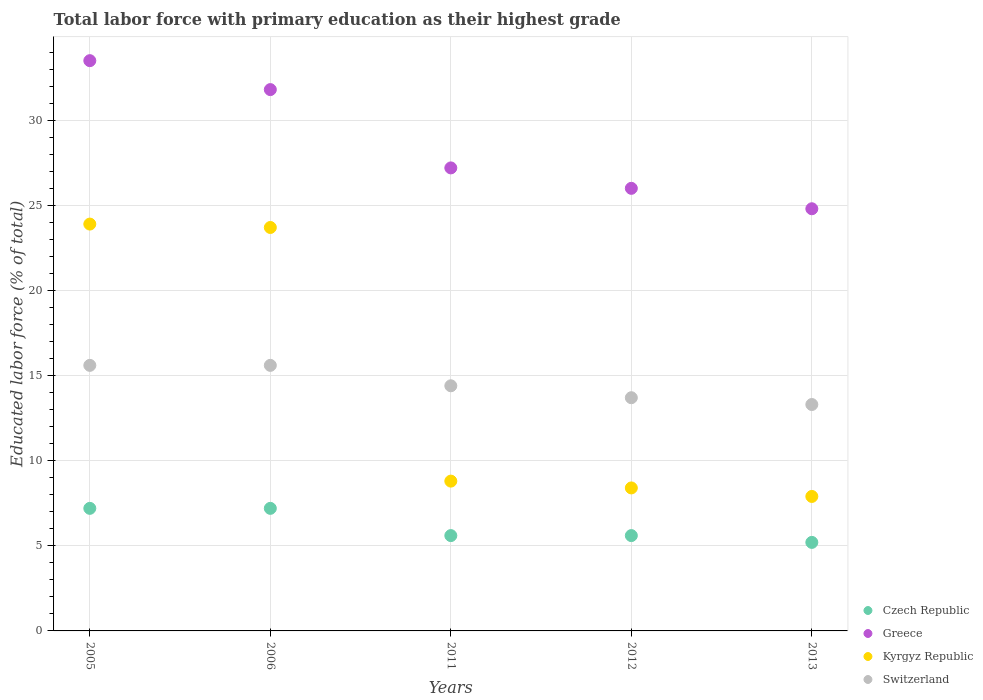What is the percentage of total labor force with primary education in Greece in 2011?
Provide a succinct answer. 27.2. Across all years, what is the maximum percentage of total labor force with primary education in Kyrgyz Republic?
Ensure brevity in your answer.  23.9. Across all years, what is the minimum percentage of total labor force with primary education in Switzerland?
Offer a terse response. 13.3. In which year was the percentage of total labor force with primary education in Greece maximum?
Your response must be concise. 2005. In which year was the percentage of total labor force with primary education in Kyrgyz Republic minimum?
Your answer should be compact. 2013. What is the total percentage of total labor force with primary education in Greece in the graph?
Offer a very short reply. 143.3. What is the difference between the percentage of total labor force with primary education in Czech Republic in 2011 and that in 2013?
Your answer should be compact. 0.4. What is the difference between the percentage of total labor force with primary education in Greece in 2006 and the percentage of total labor force with primary education in Switzerland in 2011?
Your response must be concise. 17.4. What is the average percentage of total labor force with primary education in Kyrgyz Republic per year?
Offer a terse response. 14.54. In the year 2006, what is the difference between the percentage of total labor force with primary education in Switzerland and percentage of total labor force with primary education in Czech Republic?
Keep it short and to the point. 8.4. What is the ratio of the percentage of total labor force with primary education in Switzerland in 2012 to that in 2013?
Give a very brief answer. 1.03. Is the percentage of total labor force with primary education in Czech Republic in 2005 less than that in 2011?
Provide a short and direct response. No. What is the difference between the highest and the second highest percentage of total labor force with primary education in Kyrgyz Republic?
Your response must be concise. 0.2. What is the difference between the highest and the lowest percentage of total labor force with primary education in Kyrgyz Republic?
Give a very brief answer. 16. How many dotlines are there?
Make the answer very short. 4. Does the graph contain any zero values?
Your answer should be compact. No. Does the graph contain grids?
Your response must be concise. Yes. How many legend labels are there?
Keep it short and to the point. 4. What is the title of the graph?
Give a very brief answer. Total labor force with primary education as their highest grade. Does "Mongolia" appear as one of the legend labels in the graph?
Provide a short and direct response. No. What is the label or title of the X-axis?
Offer a terse response. Years. What is the label or title of the Y-axis?
Your answer should be compact. Educated labor force (% of total). What is the Educated labor force (% of total) in Czech Republic in 2005?
Give a very brief answer. 7.2. What is the Educated labor force (% of total) in Greece in 2005?
Offer a terse response. 33.5. What is the Educated labor force (% of total) of Kyrgyz Republic in 2005?
Make the answer very short. 23.9. What is the Educated labor force (% of total) of Switzerland in 2005?
Make the answer very short. 15.6. What is the Educated labor force (% of total) in Czech Republic in 2006?
Your answer should be very brief. 7.2. What is the Educated labor force (% of total) of Greece in 2006?
Provide a short and direct response. 31.8. What is the Educated labor force (% of total) of Kyrgyz Republic in 2006?
Offer a very short reply. 23.7. What is the Educated labor force (% of total) of Switzerland in 2006?
Provide a short and direct response. 15.6. What is the Educated labor force (% of total) of Czech Republic in 2011?
Keep it short and to the point. 5.6. What is the Educated labor force (% of total) of Greece in 2011?
Offer a very short reply. 27.2. What is the Educated labor force (% of total) of Kyrgyz Republic in 2011?
Keep it short and to the point. 8.8. What is the Educated labor force (% of total) in Switzerland in 2011?
Offer a terse response. 14.4. What is the Educated labor force (% of total) in Czech Republic in 2012?
Provide a short and direct response. 5.6. What is the Educated labor force (% of total) in Kyrgyz Republic in 2012?
Offer a very short reply. 8.4. What is the Educated labor force (% of total) in Switzerland in 2012?
Your answer should be very brief. 13.7. What is the Educated labor force (% of total) in Czech Republic in 2013?
Make the answer very short. 5.2. What is the Educated labor force (% of total) in Greece in 2013?
Give a very brief answer. 24.8. What is the Educated labor force (% of total) of Kyrgyz Republic in 2013?
Ensure brevity in your answer.  7.9. What is the Educated labor force (% of total) of Switzerland in 2013?
Offer a terse response. 13.3. Across all years, what is the maximum Educated labor force (% of total) of Czech Republic?
Your response must be concise. 7.2. Across all years, what is the maximum Educated labor force (% of total) in Greece?
Make the answer very short. 33.5. Across all years, what is the maximum Educated labor force (% of total) in Kyrgyz Republic?
Your answer should be compact. 23.9. Across all years, what is the maximum Educated labor force (% of total) of Switzerland?
Your response must be concise. 15.6. Across all years, what is the minimum Educated labor force (% of total) of Czech Republic?
Provide a short and direct response. 5.2. Across all years, what is the minimum Educated labor force (% of total) of Greece?
Offer a very short reply. 24.8. Across all years, what is the minimum Educated labor force (% of total) in Kyrgyz Republic?
Offer a terse response. 7.9. Across all years, what is the minimum Educated labor force (% of total) in Switzerland?
Your answer should be very brief. 13.3. What is the total Educated labor force (% of total) in Czech Republic in the graph?
Give a very brief answer. 30.8. What is the total Educated labor force (% of total) of Greece in the graph?
Give a very brief answer. 143.3. What is the total Educated labor force (% of total) in Kyrgyz Republic in the graph?
Provide a succinct answer. 72.7. What is the total Educated labor force (% of total) of Switzerland in the graph?
Make the answer very short. 72.6. What is the difference between the Educated labor force (% of total) in Czech Republic in 2005 and that in 2006?
Give a very brief answer. 0. What is the difference between the Educated labor force (% of total) of Kyrgyz Republic in 2005 and that in 2006?
Offer a very short reply. 0.2. What is the difference between the Educated labor force (% of total) in Switzerland in 2005 and that in 2006?
Provide a succinct answer. 0. What is the difference between the Educated labor force (% of total) in Czech Republic in 2005 and that in 2011?
Offer a very short reply. 1.6. What is the difference between the Educated labor force (% of total) in Greece in 2005 and that in 2011?
Your answer should be compact. 6.3. What is the difference between the Educated labor force (% of total) of Kyrgyz Republic in 2005 and that in 2011?
Ensure brevity in your answer.  15.1. What is the difference between the Educated labor force (% of total) in Kyrgyz Republic in 2005 and that in 2012?
Make the answer very short. 15.5. What is the difference between the Educated labor force (% of total) in Switzerland in 2005 and that in 2012?
Provide a short and direct response. 1.9. What is the difference between the Educated labor force (% of total) of Czech Republic in 2005 and that in 2013?
Provide a short and direct response. 2. What is the difference between the Educated labor force (% of total) of Greece in 2005 and that in 2013?
Offer a very short reply. 8.7. What is the difference between the Educated labor force (% of total) in Kyrgyz Republic in 2005 and that in 2013?
Give a very brief answer. 16. What is the difference between the Educated labor force (% of total) in Switzerland in 2005 and that in 2013?
Offer a terse response. 2.3. What is the difference between the Educated labor force (% of total) of Czech Republic in 2006 and that in 2011?
Ensure brevity in your answer.  1.6. What is the difference between the Educated labor force (% of total) in Kyrgyz Republic in 2006 and that in 2011?
Make the answer very short. 14.9. What is the difference between the Educated labor force (% of total) of Switzerland in 2006 and that in 2011?
Your response must be concise. 1.2. What is the difference between the Educated labor force (% of total) of Kyrgyz Republic in 2006 and that in 2012?
Your answer should be compact. 15.3. What is the difference between the Educated labor force (% of total) in Switzerland in 2006 and that in 2012?
Ensure brevity in your answer.  1.9. What is the difference between the Educated labor force (% of total) in Czech Republic in 2006 and that in 2013?
Offer a terse response. 2. What is the difference between the Educated labor force (% of total) in Czech Republic in 2011 and that in 2012?
Offer a terse response. 0. What is the difference between the Educated labor force (% of total) of Greece in 2011 and that in 2012?
Ensure brevity in your answer.  1.2. What is the difference between the Educated labor force (% of total) in Greece in 2011 and that in 2013?
Make the answer very short. 2.4. What is the difference between the Educated labor force (% of total) in Kyrgyz Republic in 2011 and that in 2013?
Keep it short and to the point. 0.9. What is the difference between the Educated labor force (% of total) of Switzerland in 2011 and that in 2013?
Your answer should be compact. 1.1. What is the difference between the Educated labor force (% of total) of Czech Republic in 2012 and that in 2013?
Provide a succinct answer. 0.4. What is the difference between the Educated labor force (% of total) of Greece in 2012 and that in 2013?
Your answer should be very brief. 1.2. What is the difference between the Educated labor force (% of total) in Kyrgyz Republic in 2012 and that in 2013?
Keep it short and to the point. 0.5. What is the difference between the Educated labor force (% of total) of Switzerland in 2012 and that in 2013?
Ensure brevity in your answer.  0.4. What is the difference between the Educated labor force (% of total) of Czech Republic in 2005 and the Educated labor force (% of total) of Greece in 2006?
Offer a terse response. -24.6. What is the difference between the Educated labor force (% of total) in Czech Republic in 2005 and the Educated labor force (% of total) in Kyrgyz Republic in 2006?
Ensure brevity in your answer.  -16.5. What is the difference between the Educated labor force (% of total) of Greece in 2005 and the Educated labor force (% of total) of Switzerland in 2006?
Make the answer very short. 17.9. What is the difference between the Educated labor force (% of total) in Czech Republic in 2005 and the Educated labor force (% of total) in Switzerland in 2011?
Give a very brief answer. -7.2. What is the difference between the Educated labor force (% of total) of Greece in 2005 and the Educated labor force (% of total) of Kyrgyz Republic in 2011?
Keep it short and to the point. 24.7. What is the difference between the Educated labor force (% of total) in Czech Republic in 2005 and the Educated labor force (% of total) in Greece in 2012?
Keep it short and to the point. -18.8. What is the difference between the Educated labor force (% of total) in Czech Republic in 2005 and the Educated labor force (% of total) in Switzerland in 2012?
Provide a short and direct response. -6.5. What is the difference between the Educated labor force (% of total) of Greece in 2005 and the Educated labor force (% of total) of Kyrgyz Republic in 2012?
Your answer should be very brief. 25.1. What is the difference between the Educated labor force (% of total) in Greece in 2005 and the Educated labor force (% of total) in Switzerland in 2012?
Offer a very short reply. 19.8. What is the difference between the Educated labor force (% of total) in Czech Republic in 2005 and the Educated labor force (% of total) in Greece in 2013?
Provide a succinct answer. -17.6. What is the difference between the Educated labor force (% of total) in Czech Republic in 2005 and the Educated labor force (% of total) in Kyrgyz Republic in 2013?
Your answer should be compact. -0.7. What is the difference between the Educated labor force (% of total) in Czech Republic in 2005 and the Educated labor force (% of total) in Switzerland in 2013?
Make the answer very short. -6.1. What is the difference between the Educated labor force (% of total) of Greece in 2005 and the Educated labor force (% of total) of Kyrgyz Republic in 2013?
Give a very brief answer. 25.6. What is the difference between the Educated labor force (% of total) of Greece in 2005 and the Educated labor force (% of total) of Switzerland in 2013?
Make the answer very short. 20.2. What is the difference between the Educated labor force (% of total) of Czech Republic in 2006 and the Educated labor force (% of total) of Switzerland in 2011?
Provide a short and direct response. -7.2. What is the difference between the Educated labor force (% of total) of Greece in 2006 and the Educated labor force (% of total) of Kyrgyz Republic in 2011?
Offer a terse response. 23. What is the difference between the Educated labor force (% of total) in Kyrgyz Republic in 2006 and the Educated labor force (% of total) in Switzerland in 2011?
Offer a terse response. 9.3. What is the difference between the Educated labor force (% of total) of Czech Republic in 2006 and the Educated labor force (% of total) of Greece in 2012?
Ensure brevity in your answer.  -18.8. What is the difference between the Educated labor force (% of total) of Czech Republic in 2006 and the Educated labor force (% of total) of Kyrgyz Republic in 2012?
Offer a very short reply. -1.2. What is the difference between the Educated labor force (% of total) in Greece in 2006 and the Educated labor force (% of total) in Kyrgyz Republic in 2012?
Your response must be concise. 23.4. What is the difference between the Educated labor force (% of total) in Greece in 2006 and the Educated labor force (% of total) in Switzerland in 2012?
Offer a terse response. 18.1. What is the difference between the Educated labor force (% of total) of Kyrgyz Republic in 2006 and the Educated labor force (% of total) of Switzerland in 2012?
Provide a short and direct response. 10. What is the difference between the Educated labor force (% of total) in Czech Republic in 2006 and the Educated labor force (% of total) in Greece in 2013?
Provide a succinct answer. -17.6. What is the difference between the Educated labor force (% of total) in Greece in 2006 and the Educated labor force (% of total) in Kyrgyz Republic in 2013?
Offer a terse response. 23.9. What is the difference between the Educated labor force (% of total) of Greece in 2006 and the Educated labor force (% of total) of Switzerland in 2013?
Your answer should be very brief. 18.5. What is the difference between the Educated labor force (% of total) in Czech Republic in 2011 and the Educated labor force (% of total) in Greece in 2012?
Offer a very short reply. -20.4. What is the difference between the Educated labor force (% of total) of Czech Republic in 2011 and the Educated labor force (% of total) of Kyrgyz Republic in 2012?
Make the answer very short. -2.8. What is the difference between the Educated labor force (% of total) of Kyrgyz Republic in 2011 and the Educated labor force (% of total) of Switzerland in 2012?
Keep it short and to the point. -4.9. What is the difference between the Educated labor force (% of total) of Czech Republic in 2011 and the Educated labor force (% of total) of Greece in 2013?
Give a very brief answer. -19.2. What is the difference between the Educated labor force (% of total) in Czech Republic in 2011 and the Educated labor force (% of total) in Switzerland in 2013?
Your response must be concise. -7.7. What is the difference between the Educated labor force (% of total) of Greece in 2011 and the Educated labor force (% of total) of Kyrgyz Republic in 2013?
Make the answer very short. 19.3. What is the difference between the Educated labor force (% of total) in Greece in 2011 and the Educated labor force (% of total) in Switzerland in 2013?
Make the answer very short. 13.9. What is the difference between the Educated labor force (% of total) of Kyrgyz Republic in 2011 and the Educated labor force (% of total) of Switzerland in 2013?
Your answer should be very brief. -4.5. What is the difference between the Educated labor force (% of total) in Czech Republic in 2012 and the Educated labor force (% of total) in Greece in 2013?
Offer a very short reply. -19.2. What is the difference between the Educated labor force (% of total) of Czech Republic in 2012 and the Educated labor force (% of total) of Switzerland in 2013?
Offer a very short reply. -7.7. What is the difference between the Educated labor force (% of total) of Greece in 2012 and the Educated labor force (% of total) of Switzerland in 2013?
Your response must be concise. 12.7. What is the average Educated labor force (% of total) in Czech Republic per year?
Give a very brief answer. 6.16. What is the average Educated labor force (% of total) in Greece per year?
Keep it short and to the point. 28.66. What is the average Educated labor force (% of total) in Kyrgyz Republic per year?
Provide a succinct answer. 14.54. What is the average Educated labor force (% of total) of Switzerland per year?
Ensure brevity in your answer.  14.52. In the year 2005, what is the difference between the Educated labor force (% of total) in Czech Republic and Educated labor force (% of total) in Greece?
Keep it short and to the point. -26.3. In the year 2005, what is the difference between the Educated labor force (% of total) in Czech Republic and Educated labor force (% of total) in Kyrgyz Republic?
Give a very brief answer. -16.7. In the year 2005, what is the difference between the Educated labor force (% of total) in Czech Republic and Educated labor force (% of total) in Switzerland?
Offer a very short reply. -8.4. In the year 2005, what is the difference between the Educated labor force (% of total) in Greece and Educated labor force (% of total) in Kyrgyz Republic?
Give a very brief answer. 9.6. In the year 2005, what is the difference between the Educated labor force (% of total) in Kyrgyz Republic and Educated labor force (% of total) in Switzerland?
Give a very brief answer. 8.3. In the year 2006, what is the difference between the Educated labor force (% of total) of Czech Republic and Educated labor force (% of total) of Greece?
Offer a terse response. -24.6. In the year 2006, what is the difference between the Educated labor force (% of total) of Czech Republic and Educated labor force (% of total) of Kyrgyz Republic?
Provide a short and direct response. -16.5. In the year 2006, what is the difference between the Educated labor force (% of total) of Czech Republic and Educated labor force (% of total) of Switzerland?
Provide a short and direct response. -8.4. In the year 2006, what is the difference between the Educated labor force (% of total) in Greece and Educated labor force (% of total) in Kyrgyz Republic?
Keep it short and to the point. 8.1. In the year 2006, what is the difference between the Educated labor force (% of total) in Kyrgyz Republic and Educated labor force (% of total) in Switzerland?
Provide a short and direct response. 8.1. In the year 2011, what is the difference between the Educated labor force (% of total) of Czech Republic and Educated labor force (% of total) of Greece?
Offer a terse response. -21.6. In the year 2011, what is the difference between the Educated labor force (% of total) of Czech Republic and Educated labor force (% of total) of Kyrgyz Republic?
Give a very brief answer. -3.2. In the year 2011, what is the difference between the Educated labor force (% of total) of Greece and Educated labor force (% of total) of Switzerland?
Your response must be concise. 12.8. In the year 2011, what is the difference between the Educated labor force (% of total) in Kyrgyz Republic and Educated labor force (% of total) in Switzerland?
Provide a short and direct response. -5.6. In the year 2012, what is the difference between the Educated labor force (% of total) in Czech Republic and Educated labor force (% of total) in Greece?
Offer a terse response. -20.4. In the year 2012, what is the difference between the Educated labor force (% of total) in Czech Republic and Educated labor force (% of total) in Kyrgyz Republic?
Your answer should be very brief. -2.8. In the year 2012, what is the difference between the Educated labor force (% of total) in Czech Republic and Educated labor force (% of total) in Switzerland?
Offer a very short reply. -8.1. In the year 2012, what is the difference between the Educated labor force (% of total) of Kyrgyz Republic and Educated labor force (% of total) of Switzerland?
Your answer should be very brief. -5.3. In the year 2013, what is the difference between the Educated labor force (% of total) in Czech Republic and Educated labor force (% of total) in Greece?
Ensure brevity in your answer.  -19.6. In the year 2013, what is the difference between the Educated labor force (% of total) in Czech Republic and Educated labor force (% of total) in Kyrgyz Republic?
Offer a very short reply. -2.7. In the year 2013, what is the difference between the Educated labor force (% of total) of Kyrgyz Republic and Educated labor force (% of total) of Switzerland?
Your answer should be compact. -5.4. What is the ratio of the Educated labor force (% of total) in Czech Republic in 2005 to that in 2006?
Ensure brevity in your answer.  1. What is the ratio of the Educated labor force (% of total) in Greece in 2005 to that in 2006?
Provide a short and direct response. 1.05. What is the ratio of the Educated labor force (% of total) in Kyrgyz Republic in 2005 to that in 2006?
Offer a very short reply. 1.01. What is the ratio of the Educated labor force (% of total) of Greece in 2005 to that in 2011?
Your answer should be compact. 1.23. What is the ratio of the Educated labor force (% of total) of Kyrgyz Republic in 2005 to that in 2011?
Give a very brief answer. 2.72. What is the ratio of the Educated labor force (% of total) in Czech Republic in 2005 to that in 2012?
Provide a succinct answer. 1.29. What is the ratio of the Educated labor force (% of total) in Greece in 2005 to that in 2012?
Make the answer very short. 1.29. What is the ratio of the Educated labor force (% of total) in Kyrgyz Republic in 2005 to that in 2012?
Ensure brevity in your answer.  2.85. What is the ratio of the Educated labor force (% of total) in Switzerland in 2005 to that in 2012?
Keep it short and to the point. 1.14. What is the ratio of the Educated labor force (% of total) of Czech Republic in 2005 to that in 2013?
Give a very brief answer. 1.38. What is the ratio of the Educated labor force (% of total) in Greece in 2005 to that in 2013?
Your answer should be compact. 1.35. What is the ratio of the Educated labor force (% of total) of Kyrgyz Republic in 2005 to that in 2013?
Offer a very short reply. 3.03. What is the ratio of the Educated labor force (% of total) of Switzerland in 2005 to that in 2013?
Offer a very short reply. 1.17. What is the ratio of the Educated labor force (% of total) in Greece in 2006 to that in 2011?
Offer a terse response. 1.17. What is the ratio of the Educated labor force (% of total) of Kyrgyz Republic in 2006 to that in 2011?
Ensure brevity in your answer.  2.69. What is the ratio of the Educated labor force (% of total) of Switzerland in 2006 to that in 2011?
Offer a terse response. 1.08. What is the ratio of the Educated labor force (% of total) of Greece in 2006 to that in 2012?
Your answer should be very brief. 1.22. What is the ratio of the Educated labor force (% of total) in Kyrgyz Republic in 2006 to that in 2012?
Your response must be concise. 2.82. What is the ratio of the Educated labor force (% of total) of Switzerland in 2006 to that in 2012?
Offer a very short reply. 1.14. What is the ratio of the Educated labor force (% of total) of Czech Republic in 2006 to that in 2013?
Your response must be concise. 1.38. What is the ratio of the Educated labor force (% of total) in Greece in 2006 to that in 2013?
Keep it short and to the point. 1.28. What is the ratio of the Educated labor force (% of total) in Kyrgyz Republic in 2006 to that in 2013?
Offer a terse response. 3. What is the ratio of the Educated labor force (% of total) of Switzerland in 2006 to that in 2013?
Your answer should be very brief. 1.17. What is the ratio of the Educated labor force (% of total) of Greece in 2011 to that in 2012?
Your response must be concise. 1.05. What is the ratio of the Educated labor force (% of total) in Kyrgyz Republic in 2011 to that in 2012?
Give a very brief answer. 1.05. What is the ratio of the Educated labor force (% of total) in Switzerland in 2011 to that in 2012?
Offer a very short reply. 1.05. What is the ratio of the Educated labor force (% of total) in Greece in 2011 to that in 2013?
Provide a succinct answer. 1.1. What is the ratio of the Educated labor force (% of total) of Kyrgyz Republic in 2011 to that in 2013?
Provide a short and direct response. 1.11. What is the ratio of the Educated labor force (% of total) of Switzerland in 2011 to that in 2013?
Your response must be concise. 1.08. What is the ratio of the Educated labor force (% of total) of Greece in 2012 to that in 2013?
Offer a very short reply. 1.05. What is the ratio of the Educated labor force (% of total) of Kyrgyz Republic in 2012 to that in 2013?
Make the answer very short. 1.06. What is the ratio of the Educated labor force (% of total) of Switzerland in 2012 to that in 2013?
Offer a terse response. 1.03. What is the difference between the highest and the second highest Educated labor force (% of total) of Czech Republic?
Ensure brevity in your answer.  0. What is the difference between the highest and the second highest Educated labor force (% of total) of Greece?
Keep it short and to the point. 1.7. What is the difference between the highest and the lowest Educated labor force (% of total) of Greece?
Your answer should be very brief. 8.7. 